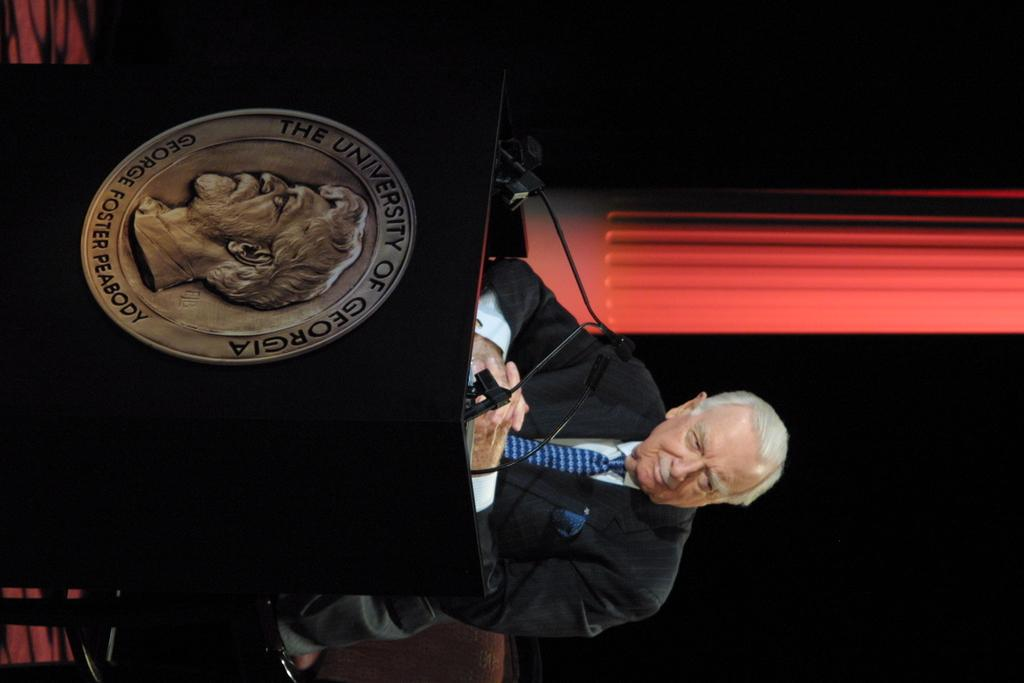Provide a one-sentence caption for the provided image. Man standing in front of a podium that has a coin from "The University of Georgia". 